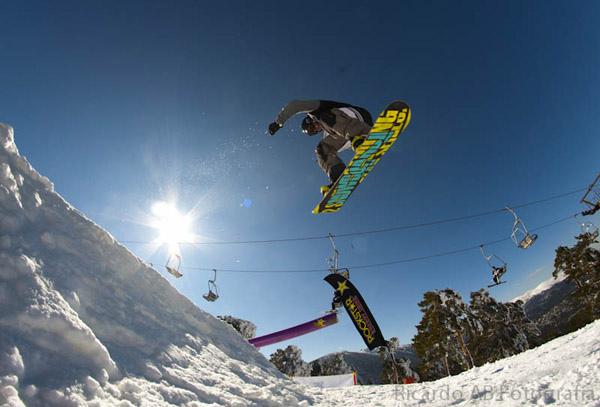What colors are his board?
Be succinct. Black yellow blue. What is the man doing?
Give a very brief answer. Snowboarding. Who is sponsoring the event?
Short answer required. Rockstar. 